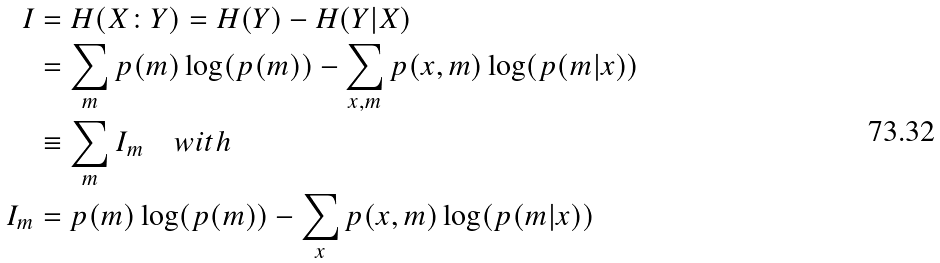<formula> <loc_0><loc_0><loc_500><loc_500>I & = H ( X \colon Y ) = H ( Y ) - H ( Y | X ) \\ & = \sum _ { m } p ( m ) \log ( p ( m ) ) - \sum _ { x , m } p ( x , m ) \log ( p ( m | x ) ) \\ & \equiv \sum _ { m } I _ { m } \quad w i t h \\ I _ { m } & = p ( m ) \log ( p ( m ) ) - \sum _ { x } p ( x , m ) \log ( p ( m | x ) )</formula> 